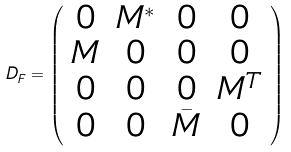Convert formula to latex. <formula><loc_0><loc_0><loc_500><loc_500>D _ { F } = \left ( \begin{array} { c c c c } 0 & M ^ { \ast } & 0 & 0 \\ M & 0 & 0 & 0 \\ 0 & 0 & 0 & M ^ { T } \\ 0 & 0 & \bar { M } & 0 \end{array} \right )</formula> 